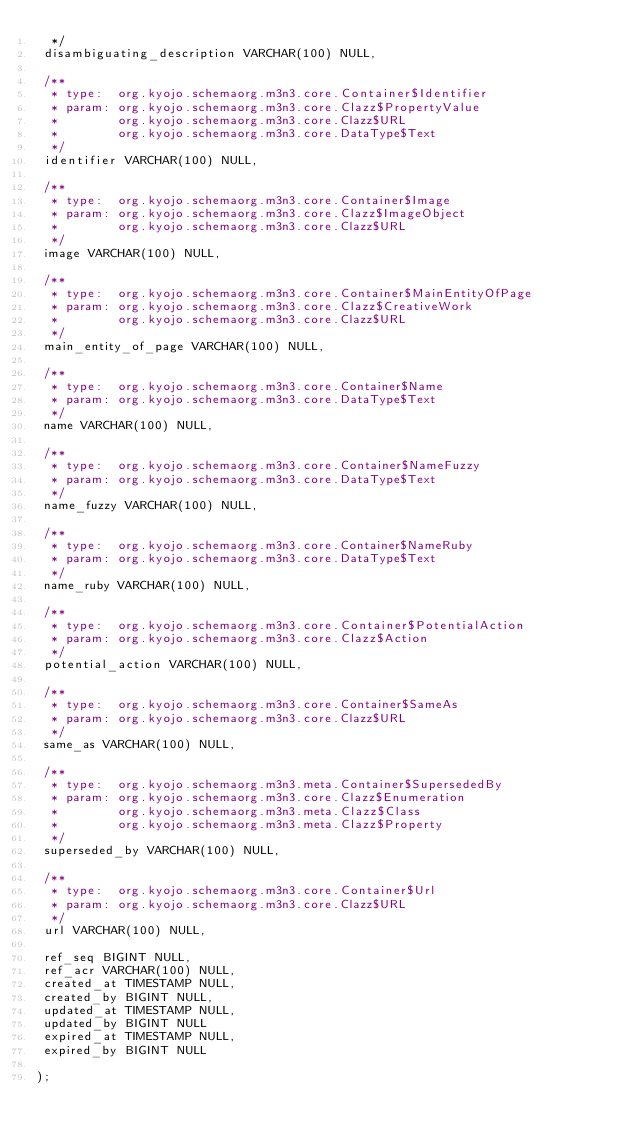Convert code to text. <code><loc_0><loc_0><loc_500><loc_500><_SQL_>  */
 disambiguating_description VARCHAR(100) NULL,

 /**
  * type:  org.kyojo.schemaorg.m3n3.core.Container$Identifier
  * param: org.kyojo.schemaorg.m3n3.core.Clazz$PropertyValue
  *        org.kyojo.schemaorg.m3n3.core.Clazz$URL
  *        org.kyojo.schemaorg.m3n3.core.DataType$Text
  */
 identifier VARCHAR(100) NULL,

 /**
  * type:  org.kyojo.schemaorg.m3n3.core.Container$Image
  * param: org.kyojo.schemaorg.m3n3.core.Clazz$ImageObject
  *        org.kyojo.schemaorg.m3n3.core.Clazz$URL
  */
 image VARCHAR(100) NULL,

 /**
  * type:  org.kyojo.schemaorg.m3n3.core.Container$MainEntityOfPage
  * param: org.kyojo.schemaorg.m3n3.core.Clazz$CreativeWork
  *        org.kyojo.schemaorg.m3n3.core.Clazz$URL
  */
 main_entity_of_page VARCHAR(100) NULL,

 /**
  * type:  org.kyojo.schemaorg.m3n3.core.Container$Name
  * param: org.kyojo.schemaorg.m3n3.core.DataType$Text
  */
 name VARCHAR(100) NULL,

 /**
  * type:  org.kyojo.schemaorg.m3n3.core.Container$NameFuzzy
  * param: org.kyojo.schemaorg.m3n3.core.DataType$Text
  */
 name_fuzzy VARCHAR(100) NULL,

 /**
  * type:  org.kyojo.schemaorg.m3n3.core.Container$NameRuby
  * param: org.kyojo.schemaorg.m3n3.core.DataType$Text
  */
 name_ruby VARCHAR(100) NULL,

 /**
  * type:  org.kyojo.schemaorg.m3n3.core.Container$PotentialAction
  * param: org.kyojo.schemaorg.m3n3.core.Clazz$Action
  */
 potential_action VARCHAR(100) NULL,

 /**
  * type:  org.kyojo.schemaorg.m3n3.core.Container$SameAs
  * param: org.kyojo.schemaorg.m3n3.core.Clazz$URL
  */
 same_as VARCHAR(100) NULL,

 /**
  * type:  org.kyojo.schemaorg.m3n3.meta.Container$SupersededBy
  * param: org.kyojo.schemaorg.m3n3.core.Clazz$Enumeration
  *        org.kyojo.schemaorg.m3n3.meta.Clazz$Class
  *        org.kyojo.schemaorg.m3n3.meta.Clazz$Property
  */
 superseded_by VARCHAR(100) NULL,

 /**
  * type:  org.kyojo.schemaorg.m3n3.core.Container$Url
  * param: org.kyojo.schemaorg.m3n3.core.Clazz$URL
  */
 url VARCHAR(100) NULL,

 ref_seq BIGINT NULL,
 ref_acr VARCHAR(100) NULL,
 created_at TIMESTAMP NULL,
 created_by BIGINT NULL,
 updated_at TIMESTAMP NULL,
 updated_by BIGINT NULL
 expired_at TIMESTAMP NULL,
 expired_by BIGINT NULL

);</code> 